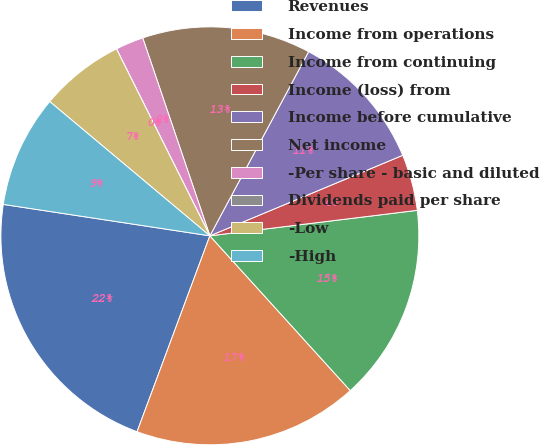Convert chart to OTSL. <chart><loc_0><loc_0><loc_500><loc_500><pie_chart><fcel>Revenues<fcel>Income from operations<fcel>Income from continuing<fcel>Income (loss) from<fcel>Income before cumulative<fcel>Net income<fcel>-Per share - basic and diluted<fcel>Dividends paid per share<fcel>-Low<fcel>-High<nl><fcel>21.74%<fcel>17.39%<fcel>15.22%<fcel>4.35%<fcel>10.87%<fcel>13.04%<fcel>2.17%<fcel>0.0%<fcel>6.52%<fcel>8.7%<nl></chart> 